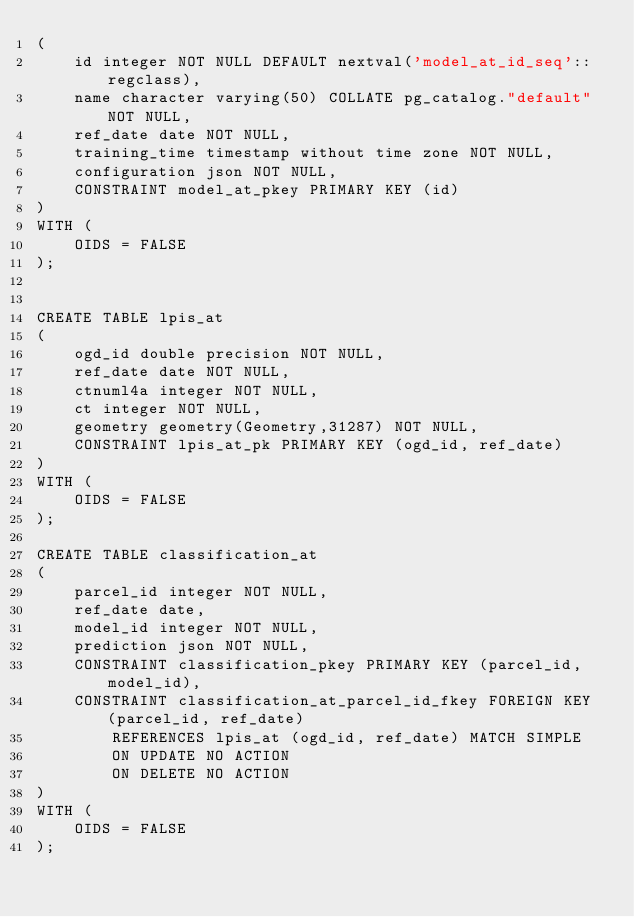<code> <loc_0><loc_0><loc_500><loc_500><_SQL_>(
    id integer NOT NULL DEFAULT nextval('model_at_id_seq'::regclass),
    name character varying(50) COLLATE pg_catalog."default" NOT NULL,
    ref_date date NOT NULL,
    training_time timestamp without time zone NOT NULL,
    configuration json NOT NULL,
    CONSTRAINT model_at_pkey PRIMARY KEY (id)
)
WITH (
    OIDS = FALSE
);
    
    
CREATE TABLE lpis_at
(
    ogd_id double precision NOT NULL,
    ref_date date NOT NULL,
    ctnuml4a integer NOT NULL,
    ct integer NOT NULL,
    geometry geometry(Geometry,31287) NOT NULL,
    CONSTRAINT lpis_at_pk PRIMARY KEY (ogd_id, ref_date)
)
WITH (
    OIDS = FALSE
);

CREATE TABLE classification_at
(
    parcel_id integer NOT NULL,
    ref_date date,
    model_id integer NOT NULL,
    prediction json NOT NULL,
    CONSTRAINT classification_pkey PRIMARY KEY (parcel_id, model_id),
    CONSTRAINT classification_at_parcel_id_fkey FOREIGN KEY (parcel_id, ref_date)
        REFERENCES lpis_at (ogd_id, ref_date) MATCH SIMPLE
        ON UPDATE NO ACTION
        ON DELETE NO ACTION
)
WITH (
    OIDS = FALSE
);
</code> 